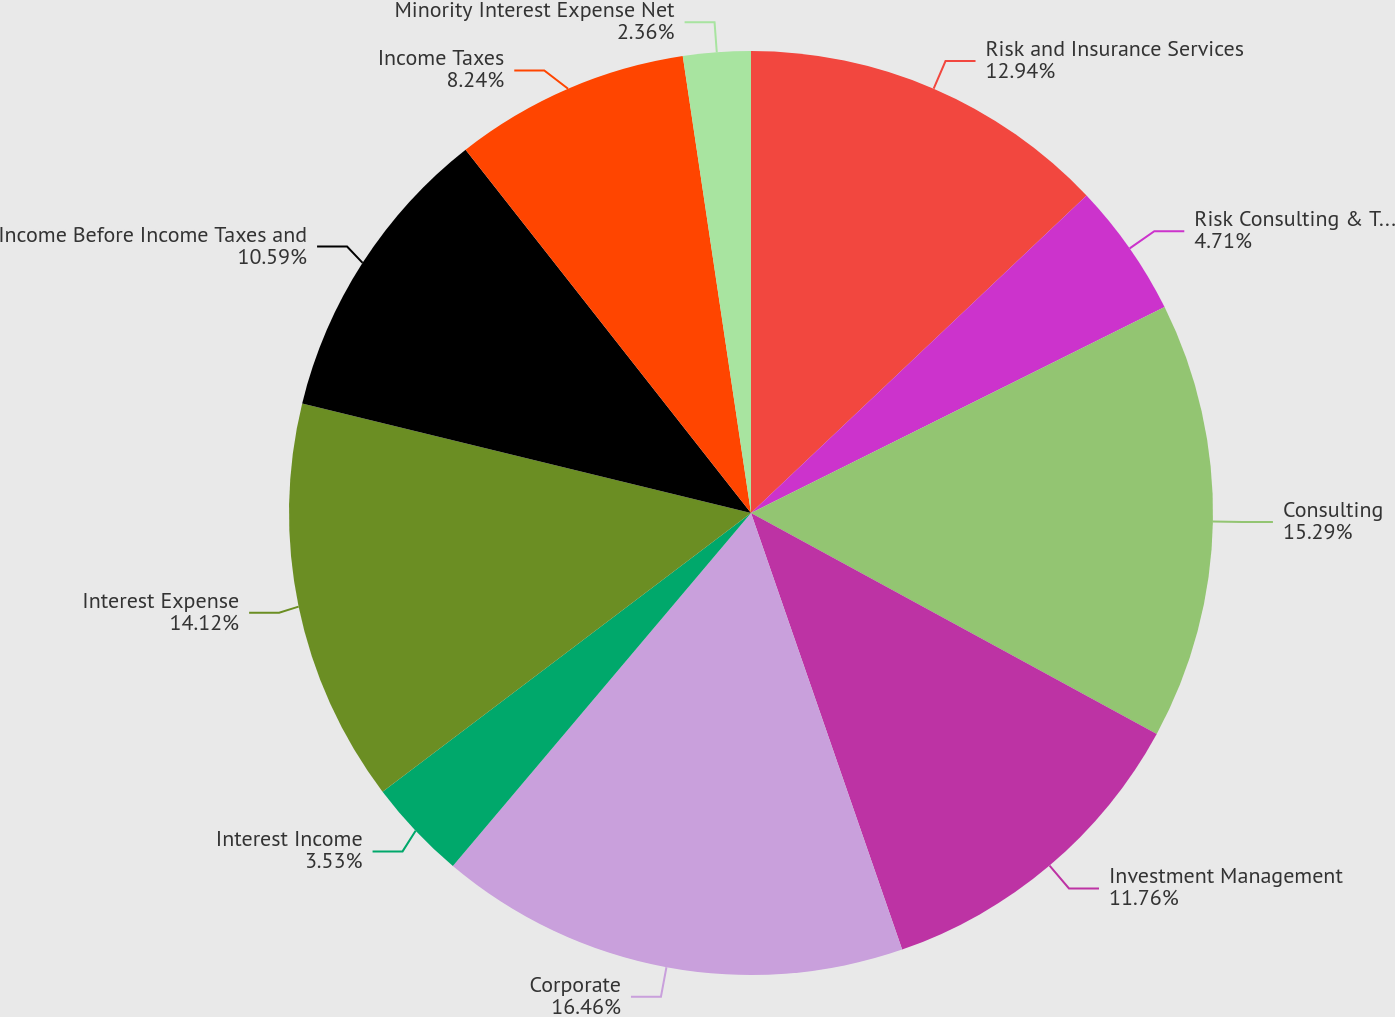Convert chart to OTSL. <chart><loc_0><loc_0><loc_500><loc_500><pie_chart><fcel>Risk and Insurance Services<fcel>Risk Consulting & Technology<fcel>Consulting<fcel>Investment Management<fcel>Corporate<fcel>Interest Income<fcel>Interest Expense<fcel>Income Before Income Taxes and<fcel>Income Taxes<fcel>Minority Interest Expense Net<nl><fcel>12.94%<fcel>4.71%<fcel>15.29%<fcel>11.76%<fcel>16.47%<fcel>3.53%<fcel>14.12%<fcel>10.59%<fcel>8.24%<fcel>2.36%<nl></chart> 